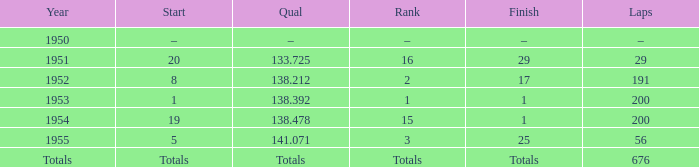What position that began at 19? 15.0. 